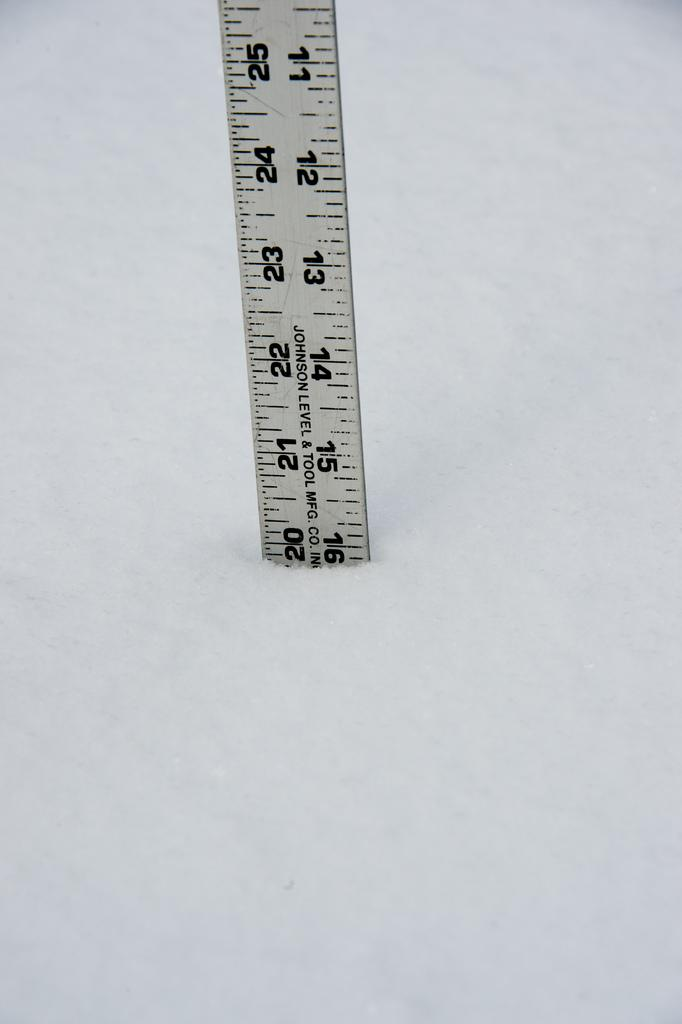<image>
Share a concise interpretation of the image provided. A ruler standing up on its end with the number 11 through 16 showing on the inches side. 